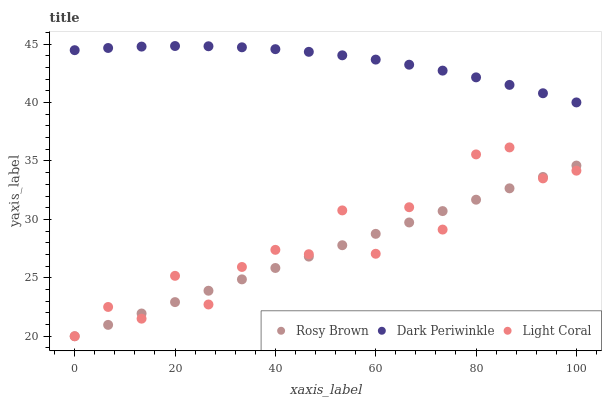Does Rosy Brown have the minimum area under the curve?
Answer yes or no. Yes. Does Dark Periwinkle have the maximum area under the curve?
Answer yes or no. Yes. Does Dark Periwinkle have the minimum area under the curve?
Answer yes or no. No. Does Rosy Brown have the maximum area under the curve?
Answer yes or no. No. Is Rosy Brown the smoothest?
Answer yes or no. Yes. Is Light Coral the roughest?
Answer yes or no. Yes. Is Dark Periwinkle the smoothest?
Answer yes or no. No. Is Dark Periwinkle the roughest?
Answer yes or no. No. Does Light Coral have the lowest value?
Answer yes or no. Yes. Does Dark Periwinkle have the lowest value?
Answer yes or no. No. Does Dark Periwinkle have the highest value?
Answer yes or no. Yes. Does Rosy Brown have the highest value?
Answer yes or no. No. Is Rosy Brown less than Dark Periwinkle?
Answer yes or no. Yes. Is Dark Periwinkle greater than Light Coral?
Answer yes or no. Yes. Does Light Coral intersect Rosy Brown?
Answer yes or no. Yes. Is Light Coral less than Rosy Brown?
Answer yes or no. No. Is Light Coral greater than Rosy Brown?
Answer yes or no. No. Does Rosy Brown intersect Dark Periwinkle?
Answer yes or no. No. 